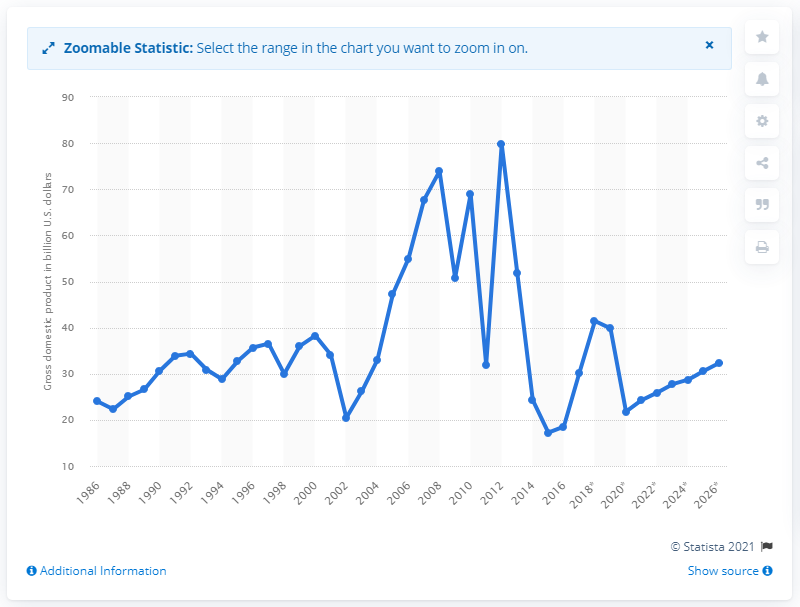Indicate a few pertinent items in this graphic. In 2017, Libya's gross domestic product (GDP) was estimated to be approximately 30.21 billion dollars. 